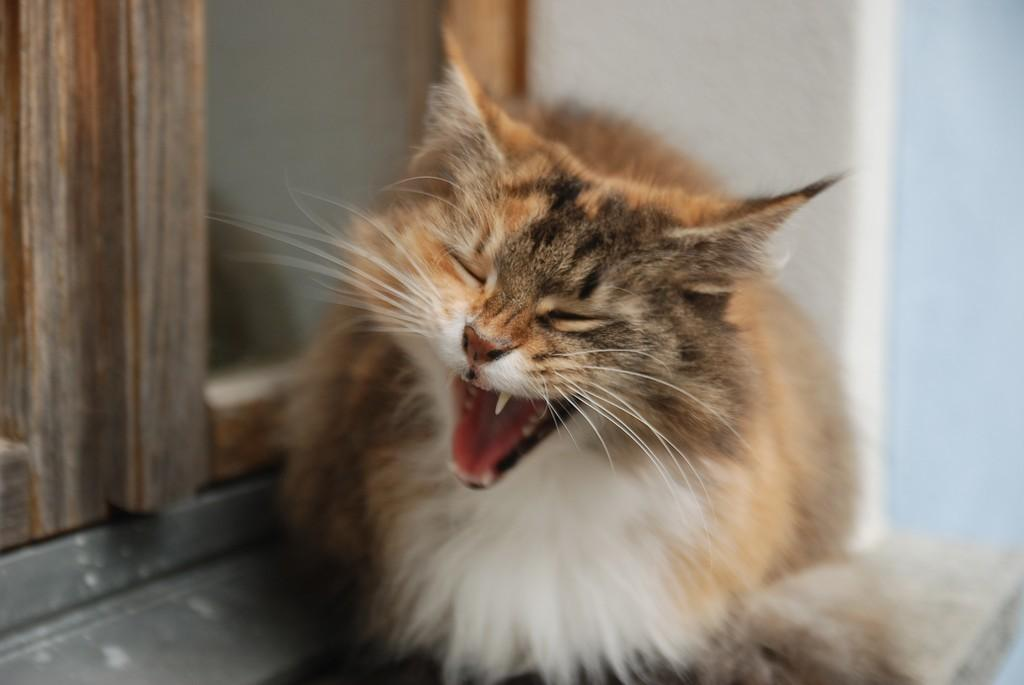What type of animal can be seen in the image? There is a cat in the image. Where is the cat positioned in the image? The cat is sitting on a platform. What is the location of the platform in the image? The platform is located at the window doors. What can be seen in the background of the image? There is a wall in the image. What type of education does the cat receive in the image? There is no indication in the image that the cat is receiving any education. How far is the hospital from the location depicted in the image? The image does not provide any information about the distance to a hospital, nor does it depict a hospital. 